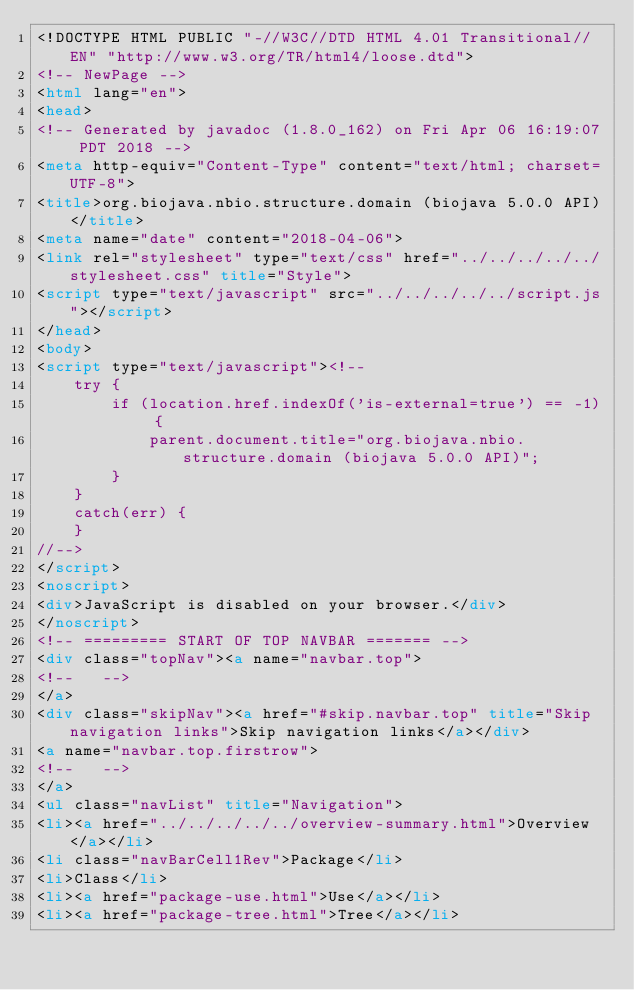Convert code to text. <code><loc_0><loc_0><loc_500><loc_500><_HTML_><!DOCTYPE HTML PUBLIC "-//W3C//DTD HTML 4.01 Transitional//EN" "http://www.w3.org/TR/html4/loose.dtd">
<!-- NewPage -->
<html lang="en">
<head>
<!-- Generated by javadoc (1.8.0_162) on Fri Apr 06 16:19:07 PDT 2018 -->
<meta http-equiv="Content-Type" content="text/html; charset=UTF-8">
<title>org.biojava.nbio.structure.domain (biojava 5.0.0 API)</title>
<meta name="date" content="2018-04-06">
<link rel="stylesheet" type="text/css" href="../../../../../stylesheet.css" title="Style">
<script type="text/javascript" src="../../../../../script.js"></script>
</head>
<body>
<script type="text/javascript"><!--
    try {
        if (location.href.indexOf('is-external=true') == -1) {
            parent.document.title="org.biojava.nbio.structure.domain (biojava 5.0.0 API)";
        }
    }
    catch(err) {
    }
//-->
</script>
<noscript>
<div>JavaScript is disabled on your browser.</div>
</noscript>
<!-- ========= START OF TOP NAVBAR ======= -->
<div class="topNav"><a name="navbar.top">
<!--   -->
</a>
<div class="skipNav"><a href="#skip.navbar.top" title="Skip navigation links">Skip navigation links</a></div>
<a name="navbar.top.firstrow">
<!--   -->
</a>
<ul class="navList" title="Navigation">
<li><a href="../../../../../overview-summary.html">Overview</a></li>
<li class="navBarCell1Rev">Package</li>
<li>Class</li>
<li><a href="package-use.html">Use</a></li>
<li><a href="package-tree.html">Tree</a></li></code> 